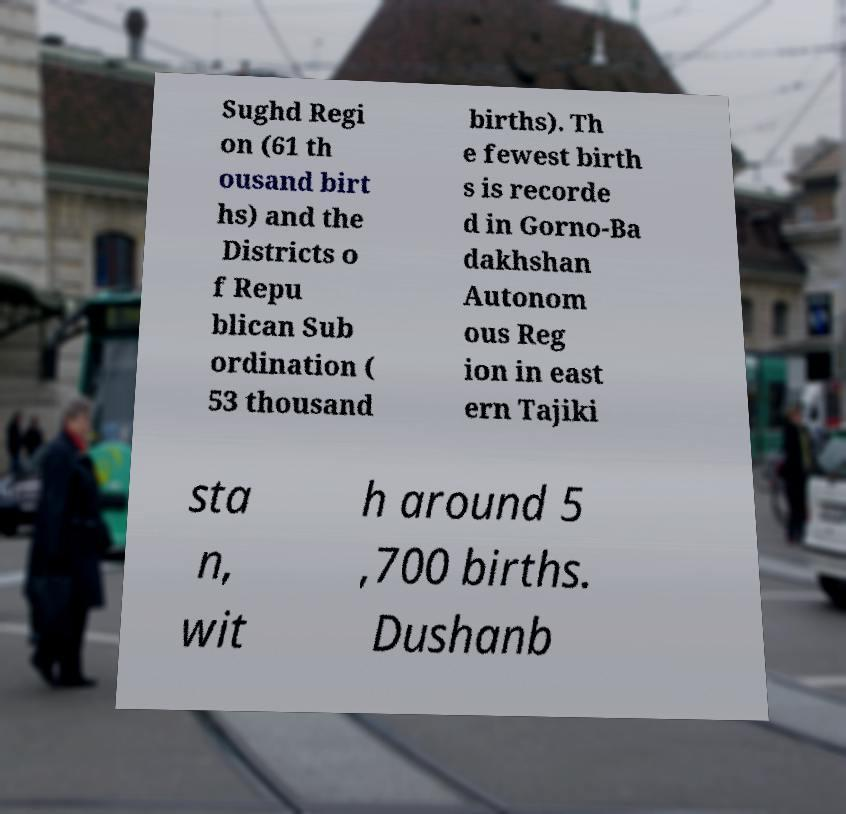There's text embedded in this image that I need extracted. Can you transcribe it verbatim? Sughd Regi on (61 th ousand birt hs) and the Districts o f Repu blican Sub ordination ( 53 thousand births). Th e fewest birth s is recorde d in Gorno-Ba dakhshan Autonom ous Reg ion in east ern Tajiki sta n, wit h around 5 ,700 births. Dushanb 